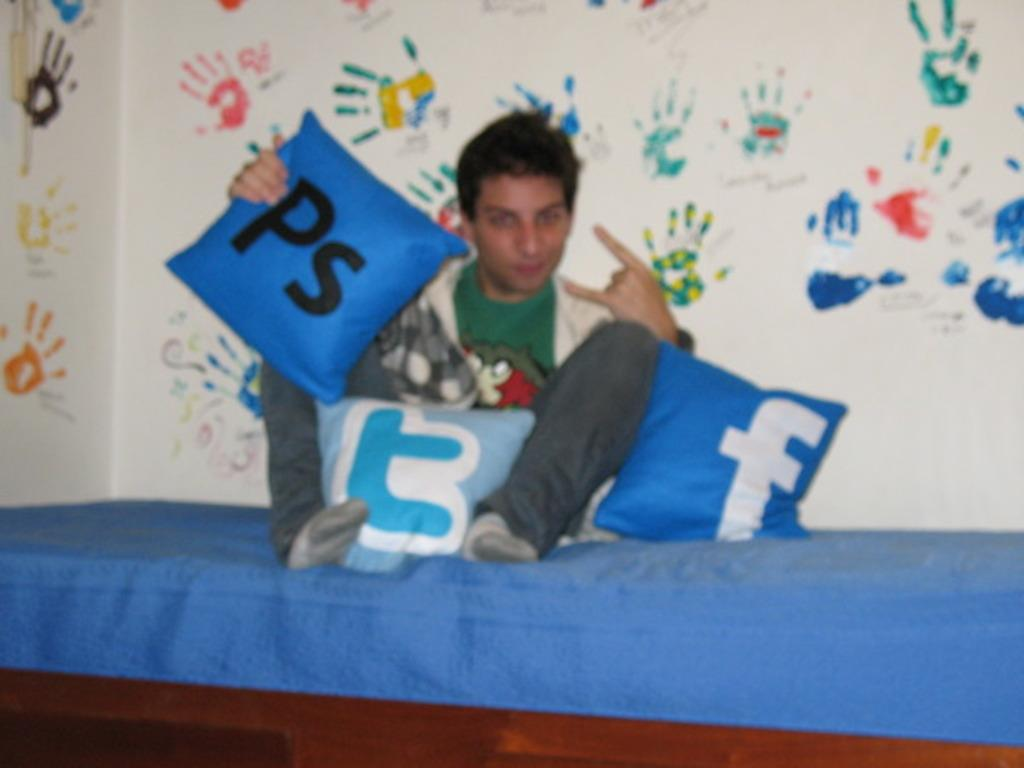<image>
Share a concise interpretation of the image provided. A young man sits on a bed with pillows with social media and application icons on pillows around him. 